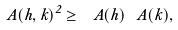Convert formula to latex. <formula><loc_0><loc_0><loc_500><loc_500>\ A ( h , k ) ^ { 2 } \geq \ A ( h ) \ A ( k ) ,</formula> 